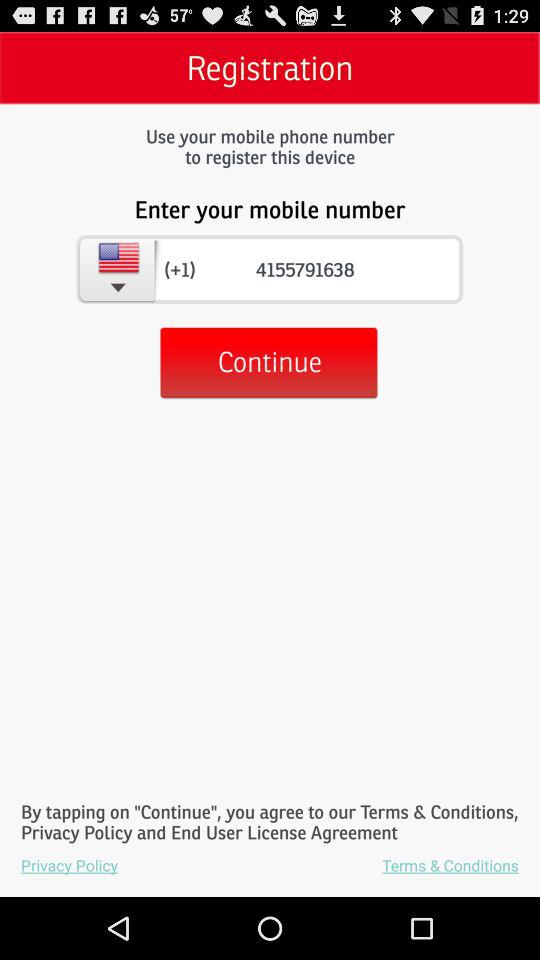What is the mobile number? The mobile number is (+1) 4155791638. 